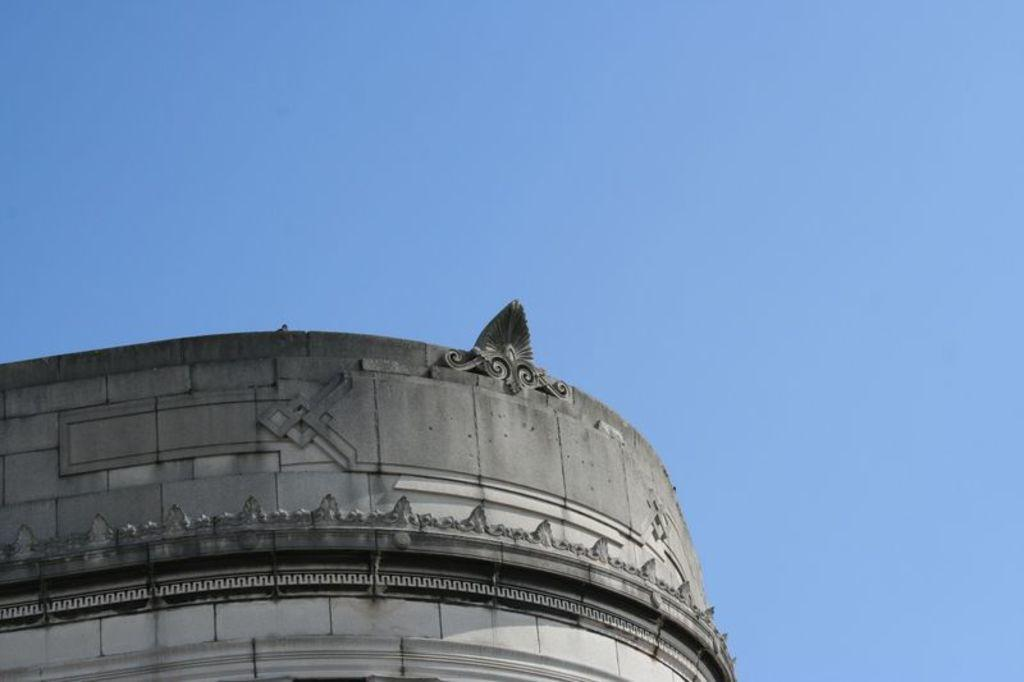What type of structure is present in the image? There is a building in the image. What design element can be seen on the wall of the building? There is a floral design on the wall of the building. What is visible at the top of the image? The sky is visible at the top of the image. What type of basin is located on the roof of the building in the image? There is no basin present on the roof of the building in the image. 